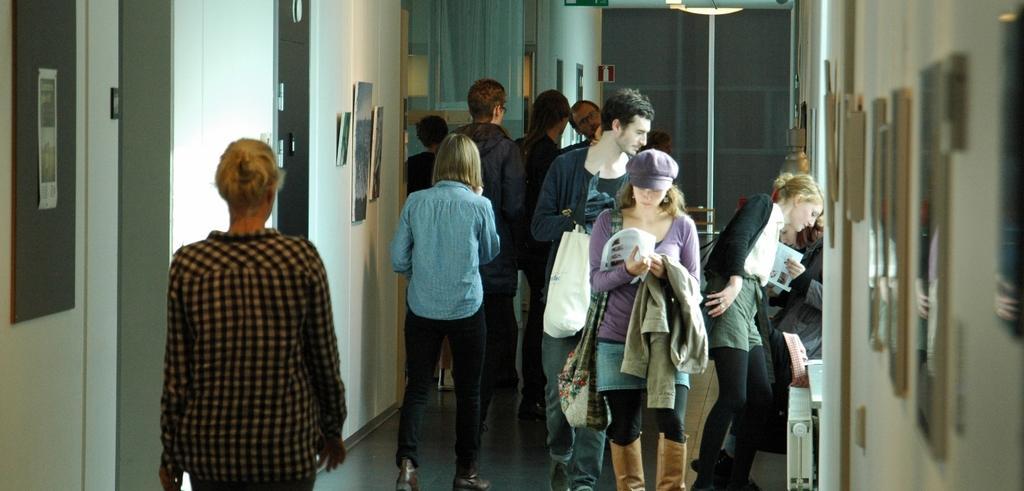In one or two sentences, can you explain what this image depicts? In this image there are group of people standing , there are frames attached to the wall, light. 